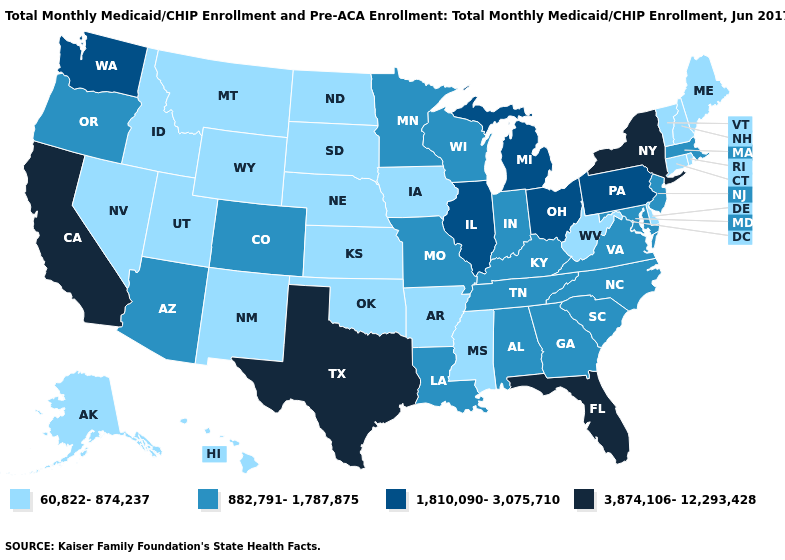Which states have the lowest value in the MidWest?
Write a very short answer. Iowa, Kansas, Nebraska, North Dakota, South Dakota. Which states have the lowest value in the USA?
Quick response, please. Alaska, Arkansas, Connecticut, Delaware, Hawaii, Idaho, Iowa, Kansas, Maine, Mississippi, Montana, Nebraska, Nevada, New Hampshire, New Mexico, North Dakota, Oklahoma, Rhode Island, South Dakota, Utah, Vermont, West Virginia, Wyoming. Among the states that border West Virginia , does Pennsylvania have the highest value?
Answer briefly. Yes. Name the states that have a value in the range 882,791-1,787,875?
Write a very short answer. Alabama, Arizona, Colorado, Georgia, Indiana, Kentucky, Louisiana, Maryland, Massachusetts, Minnesota, Missouri, New Jersey, North Carolina, Oregon, South Carolina, Tennessee, Virginia, Wisconsin. Among the states that border South Dakota , does Minnesota have the highest value?
Quick response, please. Yes. What is the highest value in states that border Florida?
Answer briefly. 882,791-1,787,875. Name the states that have a value in the range 1,810,090-3,075,710?
Write a very short answer. Illinois, Michigan, Ohio, Pennsylvania, Washington. Does the first symbol in the legend represent the smallest category?
Write a very short answer. Yes. What is the value of Iowa?
Keep it brief. 60,822-874,237. Name the states that have a value in the range 60,822-874,237?
Keep it brief. Alaska, Arkansas, Connecticut, Delaware, Hawaii, Idaho, Iowa, Kansas, Maine, Mississippi, Montana, Nebraska, Nevada, New Hampshire, New Mexico, North Dakota, Oklahoma, Rhode Island, South Dakota, Utah, Vermont, West Virginia, Wyoming. Which states hav the highest value in the Northeast?
Answer briefly. New York. What is the lowest value in the South?
Quick response, please. 60,822-874,237. Does Colorado have a lower value than Mississippi?
Quick response, please. No. Which states have the lowest value in the West?
Short answer required. Alaska, Hawaii, Idaho, Montana, Nevada, New Mexico, Utah, Wyoming. Does Kentucky have the lowest value in the USA?
Give a very brief answer. No. 